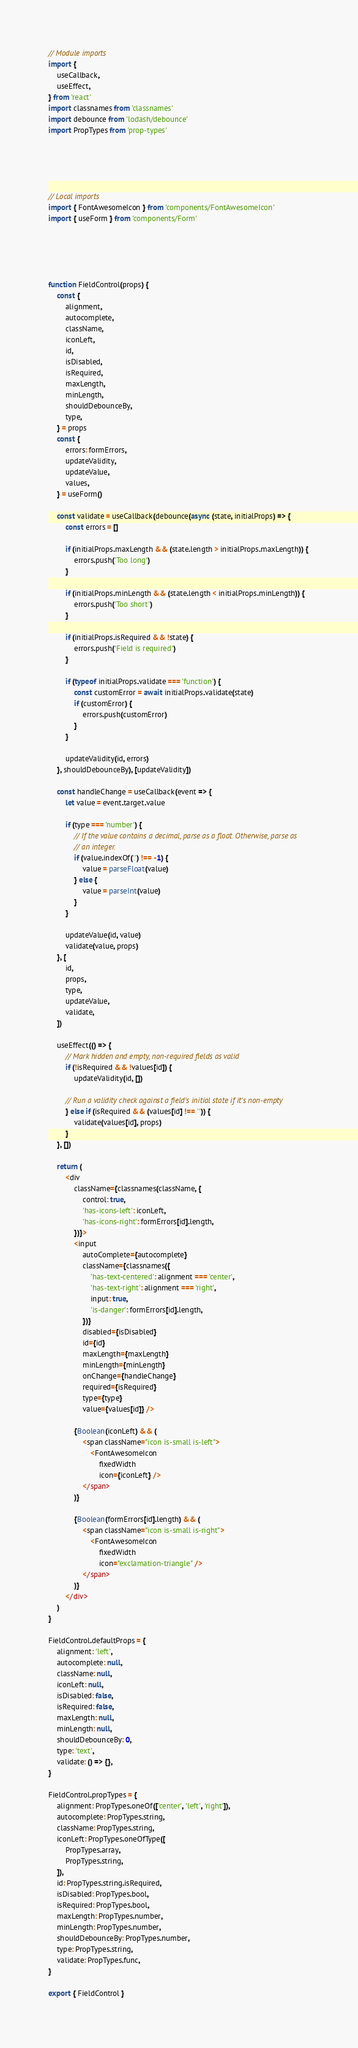<code> <loc_0><loc_0><loc_500><loc_500><_JavaScript_>// Module imports
import {
	useCallback,
	useEffect,
} from 'react'
import classnames from 'classnames'
import debounce from 'lodash/debounce'
import PropTypes from 'prop-types'





// Local imports
import { FontAwesomeIcon } from 'components/FontAwesomeIcon'
import { useForm } from 'components/Form'





function FieldControl(props) {
	const {
		alignment,
		autocomplete,
		className,
		iconLeft,
		id,
		isDisabled,
		isRequired,
		maxLength,
		minLength,
		shouldDebounceBy,
		type,
	} = props
	const {
		errors: formErrors,
		updateValidity,
		updateValue,
		values,
	} = useForm()

	const validate = useCallback(debounce(async (state, initialProps) => {
		const errors = []

		if (initialProps.maxLength && (state.length > initialProps.maxLength)) {
			errors.push('Too long')
		}

		if (initialProps.minLength && (state.length < initialProps.minLength)) {
			errors.push('Too short')
		}

		if (initialProps.isRequired && !state) {
			errors.push('Field is required')
		}

		if (typeof initialProps.validate === 'function') {
			const customError = await initialProps.validate(state)
			if (customError) {
				errors.push(customError)
			}
		}

		updateValidity(id, errors)
	}, shouldDebounceBy), [updateValidity])

	const handleChange = useCallback(event => {
		let value = event.target.value

		if (type === 'number') {
			// If the value contains a decimal, parse as a float. Otherwise, parse as
			// an integer.
			if (value.indexOf('.') !== -1) {
				value = parseFloat(value)
			} else {
				value = parseInt(value)
			}
		}

		updateValue(id, value)
		validate(value, props)
	}, [
		id,
		props,
		type,
		updateValue,
		validate,
	])

	useEffect(() => {
		// Mark hidden and empty, non-required fields as valid
		if (!isRequired && !values[id]) {
			updateValidity(id, [])

		// Run a validity check against a field's initial state if it's non-empty
		} else if (isRequired && (values[id] !== '')) {
			validate(values[id], props)
		}
	}, [])

	return (
		<div
			className={classnames(className, {
				control: true,
				'has-icons-left': iconLeft,
				'has-icons-right': formErrors[id].length,
			})}>
			<input
				autoComplete={autocomplete}
				className={classnames({
					'has-text-centered': alignment === 'center',
					'has-text-right': alignment === 'right',
					input: true,
					'is-danger': formErrors[id].length,
				})}
				disabled={isDisabled}
				id={id}
				maxLength={maxLength}
				minLength={minLength}
				onChange={handleChange}
				required={isRequired}
				type={type}
				value={values[id]} />

			{Boolean(iconLeft) && (
				<span className="icon is-small is-left">
					<FontAwesomeIcon
						fixedWidth
						icon={iconLeft} />
				</span>
			)}

			{Boolean(formErrors[id].length) && (
				<span className="icon is-small is-right">
					<FontAwesomeIcon
						fixedWidth
						icon="exclamation-triangle" />
				</span>
			)}
		</div>
	)
}

FieldControl.defaultProps = {
	alignment: 'left',
	autocomplete: null,
	className: null,
	iconLeft: null,
	isDisabled: false,
	isRequired: false,
	maxLength: null,
	minLength: null,
	shouldDebounceBy: 0,
	type: 'text',
	validate: () => {},
}

FieldControl.propTypes = {
	alignment: PropTypes.oneOf(['center', 'left', 'right']),
	autocomplete: PropTypes.string,
	className: PropTypes.string,
	iconLeft: PropTypes.oneOfType([
		PropTypes.array,
		PropTypes.string,
	]),
	id: PropTypes.string.isRequired,
	isDisabled: PropTypes.bool,
	isRequired: PropTypes.bool,
	maxLength: PropTypes.number,
	minLength: PropTypes.number,
	shouldDebounceBy: PropTypes.number,
	type: PropTypes.string,
	validate: PropTypes.func,
}

export { FieldControl }
</code> 